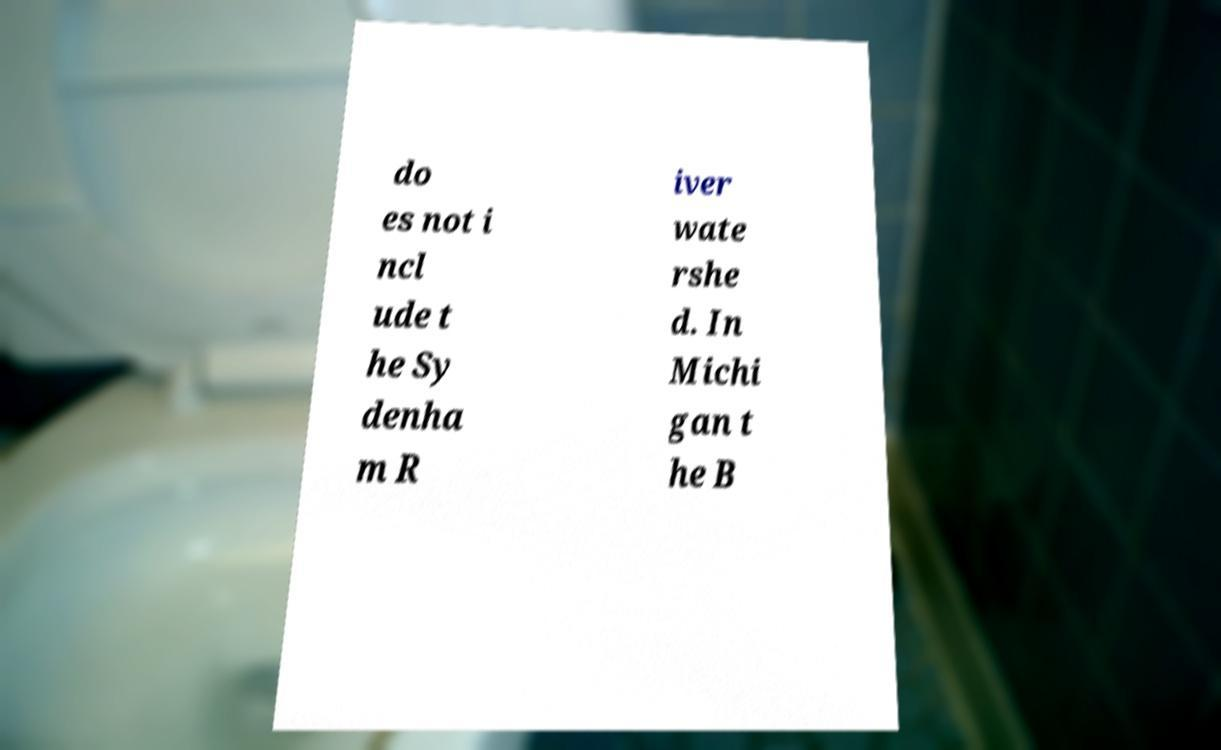For documentation purposes, I need the text within this image transcribed. Could you provide that? do es not i ncl ude t he Sy denha m R iver wate rshe d. In Michi gan t he B 